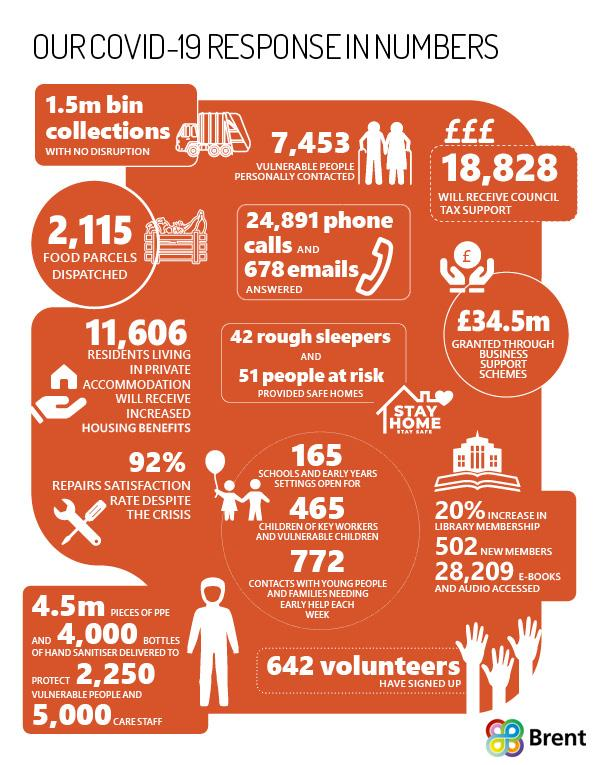Identify some key points in this picture. The fund granted through business support schemes in Brent totals £34.5 million. Six hundred and forty-two volunteers are dedicated to working in Brent's COVID-19 mission. As part of Brent's Covid-19 mission, a total of 11,606 residents living in private accommodation will receive an increase in housing benefits. The Covid-19 mission of Brent personal contacted 7,453 vulnerable individuals. The financial assistance offered by Brent for Council tax support is 18,828 pounds. 